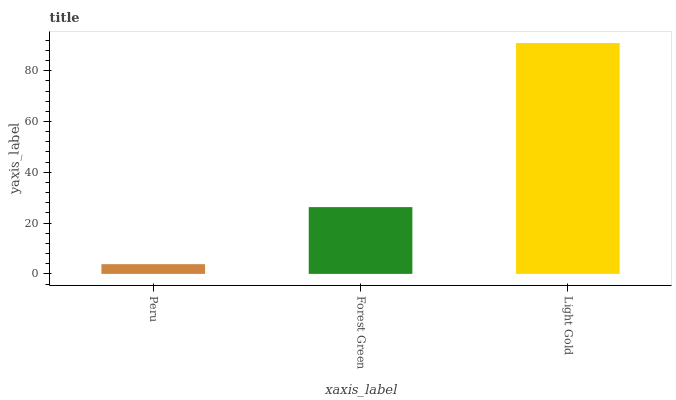Is Peru the minimum?
Answer yes or no. Yes. Is Light Gold the maximum?
Answer yes or no. Yes. Is Forest Green the minimum?
Answer yes or no. No. Is Forest Green the maximum?
Answer yes or no. No. Is Forest Green greater than Peru?
Answer yes or no. Yes. Is Peru less than Forest Green?
Answer yes or no. Yes. Is Peru greater than Forest Green?
Answer yes or no. No. Is Forest Green less than Peru?
Answer yes or no. No. Is Forest Green the high median?
Answer yes or no. Yes. Is Forest Green the low median?
Answer yes or no. Yes. Is Peru the high median?
Answer yes or no. No. Is Peru the low median?
Answer yes or no. No. 